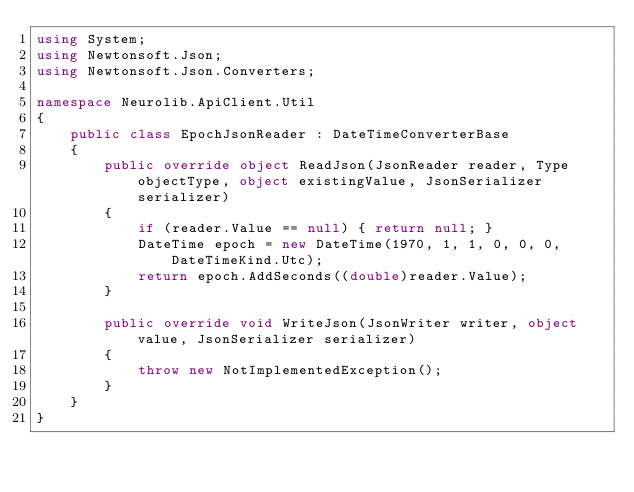Convert code to text. <code><loc_0><loc_0><loc_500><loc_500><_C#_>using System;
using Newtonsoft.Json;
using Newtonsoft.Json.Converters;

namespace Neurolib.ApiClient.Util
{
    public class EpochJsonReader : DateTimeConverterBase
    {
        public override object ReadJson(JsonReader reader, Type objectType, object existingValue, JsonSerializer serializer)
        {
            if (reader.Value == null) { return null; }
            DateTime epoch = new DateTime(1970, 1, 1, 0, 0, 0, DateTimeKind.Utc);
            return epoch.AddSeconds((double)reader.Value);
        }

        public override void WriteJson(JsonWriter writer, object value, JsonSerializer serializer)
        {
            throw new NotImplementedException();
        }
    }
}</code> 